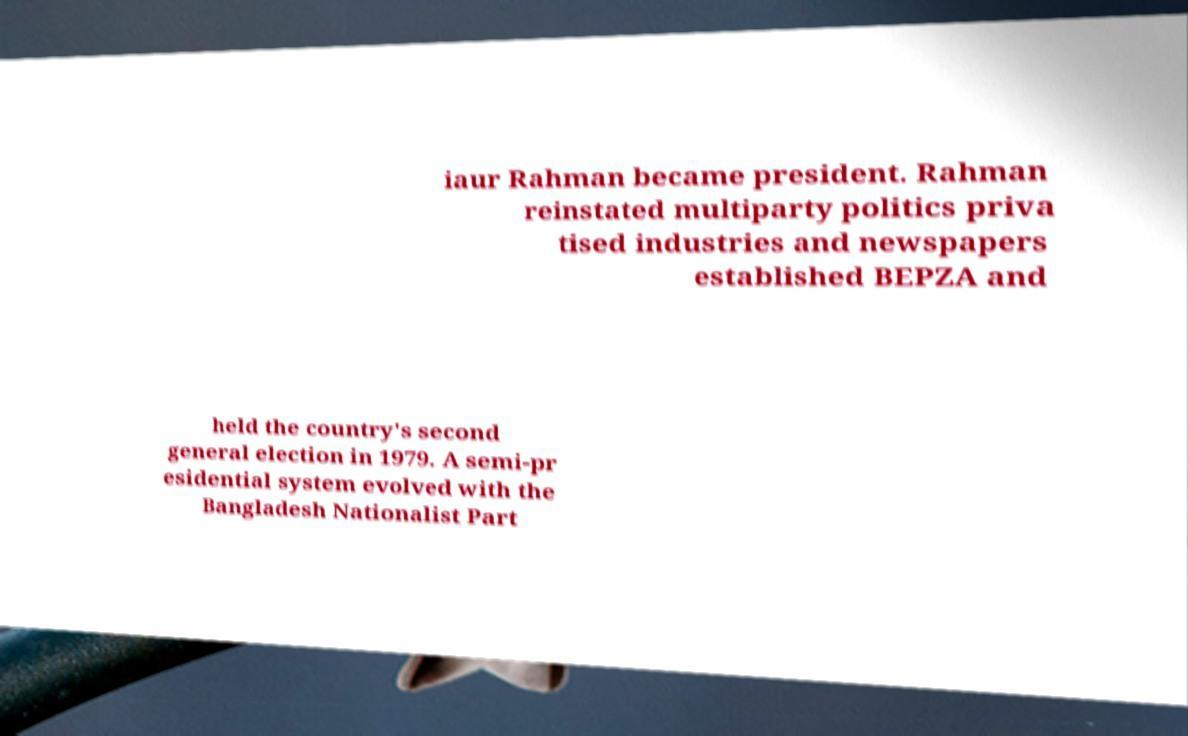Could you extract and type out the text from this image? iaur Rahman became president. Rahman reinstated multiparty politics priva tised industries and newspapers established BEPZA and held the country's second general election in 1979. A semi-pr esidential system evolved with the Bangladesh Nationalist Part 